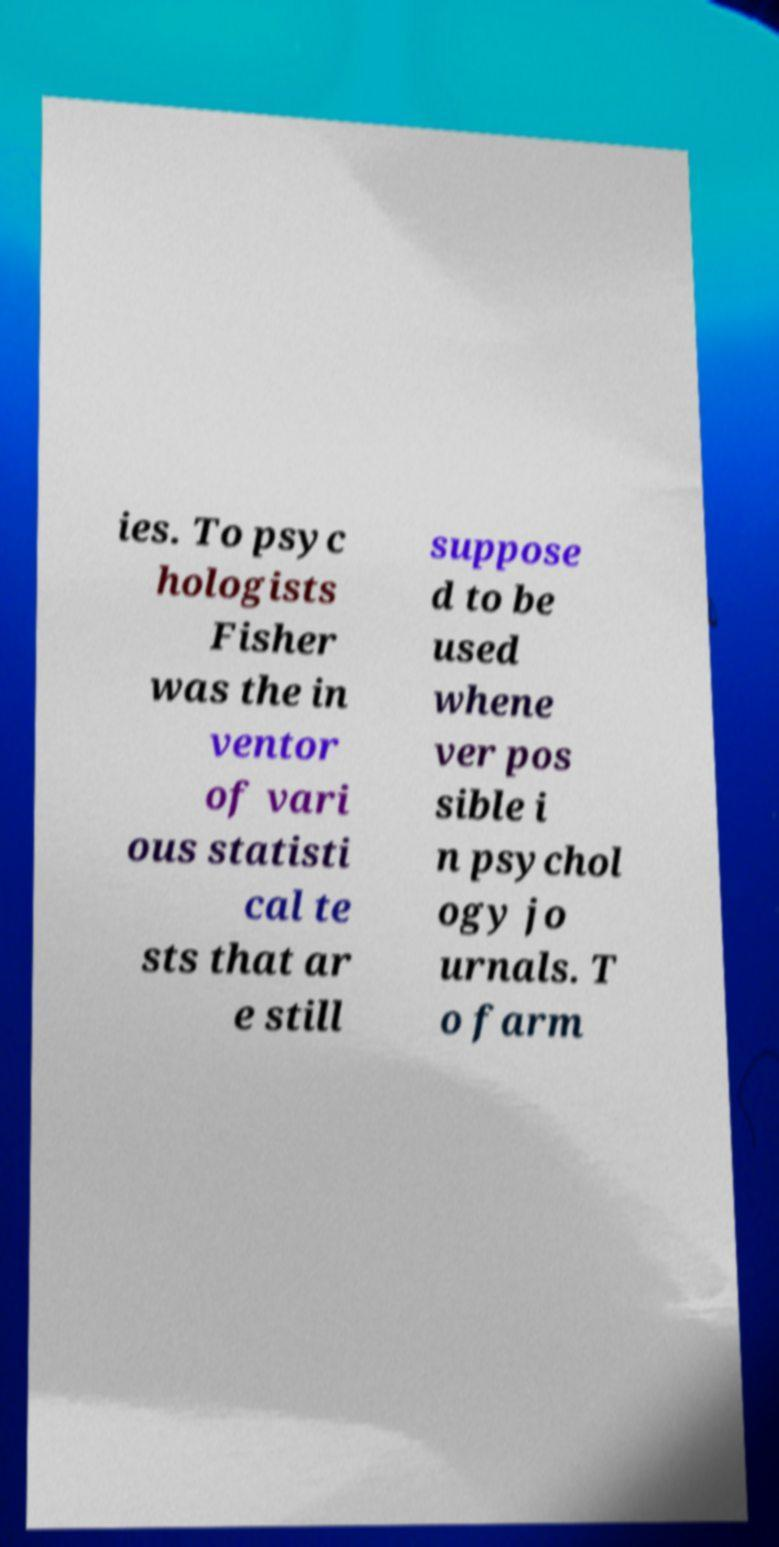For documentation purposes, I need the text within this image transcribed. Could you provide that? ies. To psyc hologists Fisher was the in ventor of vari ous statisti cal te sts that ar e still suppose d to be used whene ver pos sible i n psychol ogy jo urnals. T o farm 